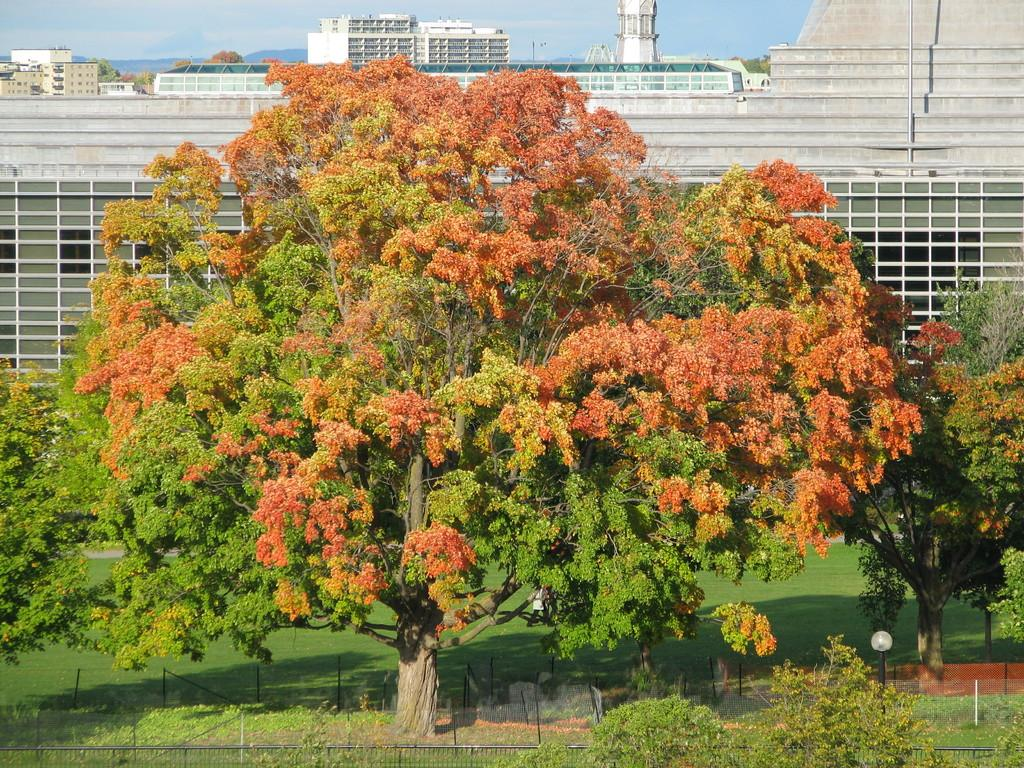What type of view is shown in the image? The image is an outside view. What can be seen at the bottom of the image? There is a garden at the bottom of the image. What is present in the garden? There are many plants and trees in the garden. What is visible in the background of the image? There are buildings in the background of the image. What is visible at the top of the image? The sky is visible at the top of the image. What type of whip is being used to trim the plants in the garden? There is no whip present in the image, and no trimming activity is depicted. What color is the skirt of the person standing in the garden? There is no person present in the image, and therefore no skirt to describe. 